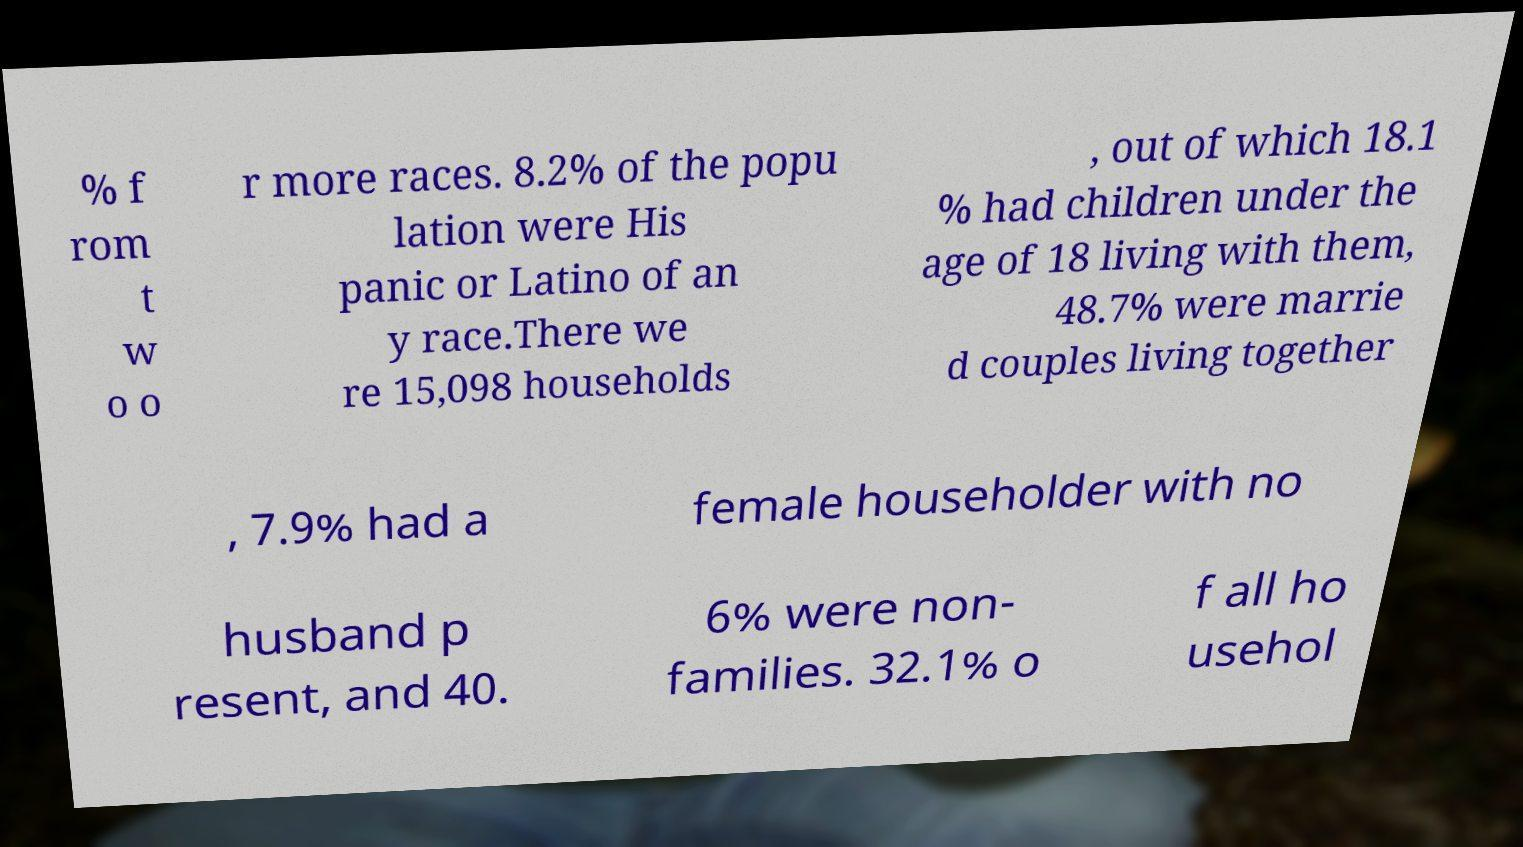Could you extract and type out the text from this image? % f rom t w o o r more races. 8.2% of the popu lation were His panic or Latino of an y race.There we re 15,098 households , out of which 18.1 % had children under the age of 18 living with them, 48.7% were marrie d couples living together , 7.9% had a female householder with no husband p resent, and 40. 6% were non- families. 32.1% o f all ho usehol 